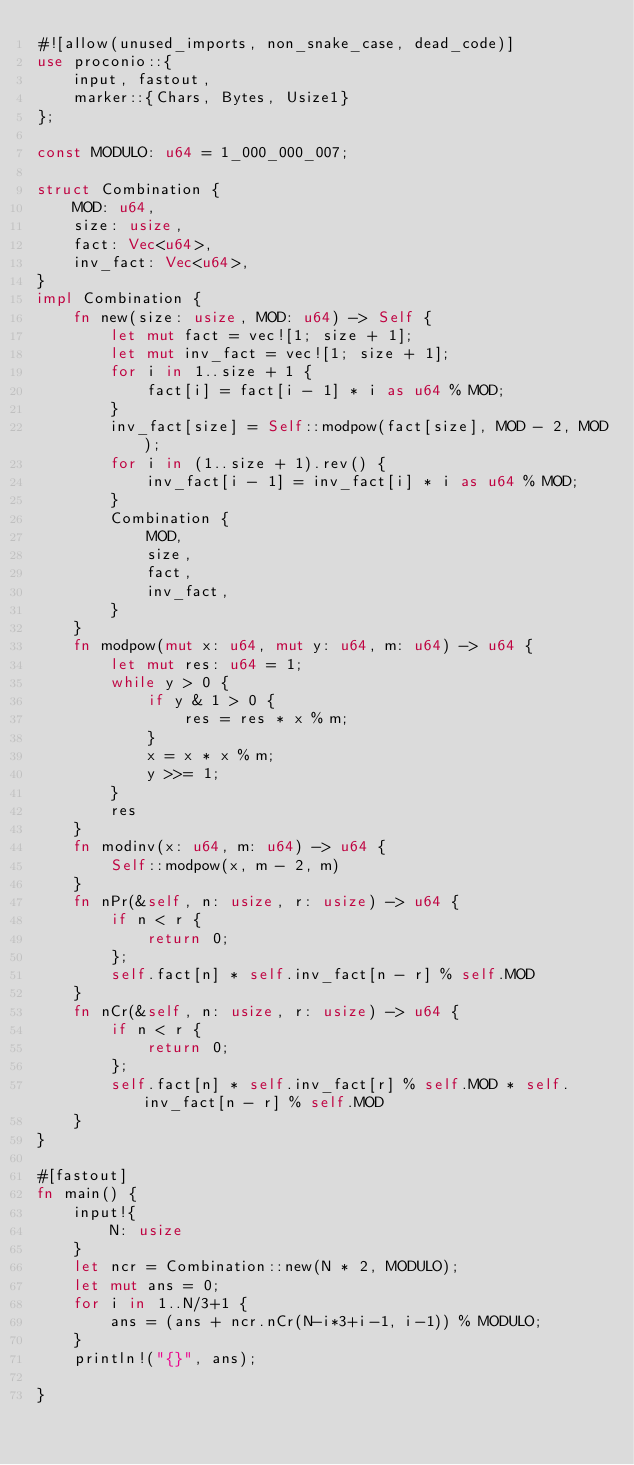Convert code to text. <code><loc_0><loc_0><loc_500><loc_500><_Rust_>#![allow(unused_imports, non_snake_case, dead_code)]
use proconio::{
    input, fastout,
    marker::{Chars, Bytes, Usize1}
};

const MODULO: u64 = 1_000_000_007;

struct Combination {
    MOD: u64,
    size: usize,
    fact: Vec<u64>,
    inv_fact: Vec<u64>,
}
impl Combination {
    fn new(size: usize, MOD: u64) -> Self {
        let mut fact = vec![1; size + 1];
        let mut inv_fact = vec![1; size + 1];
        for i in 1..size + 1 {
            fact[i] = fact[i - 1] * i as u64 % MOD;
        }
        inv_fact[size] = Self::modpow(fact[size], MOD - 2, MOD);
        for i in (1..size + 1).rev() {
            inv_fact[i - 1] = inv_fact[i] * i as u64 % MOD;
        }
        Combination {
            MOD,
            size,
            fact,
            inv_fact,
        }
    }
    fn modpow(mut x: u64, mut y: u64, m: u64) -> u64 {
        let mut res: u64 = 1;
        while y > 0 {
            if y & 1 > 0 {
                res = res * x % m;
            }
            x = x * x % m;
            y >>= 1;
        }
        res
    }
    fn modinv(x: u64, m: u64) -> u64 {
        Self::modpow(x, m - 2, m)
    }
    fn nPr(&self, n: usize, r: usize) -> u64 {
        if n < r {
            return 0;
        };
        self.fact[n] * self.inv_fact[n - r] % self.MOD
    }
    fn nCr(&self, n: usize, r: usize) -> u64 {
        if n < r {
            return 0;
        };
        self.fact[n] * self.inv_fact[r] % self.MOD * self.inv_fact[n - r] % self.MOD
    }
}

#[fastout]
fn main() {
    input!{
        N: usize
    }
    let ncr = Combination::new(N * 2, MODULO);
    let mut ans = 0;
    for i in 1..N/3+1 {
        ans = (ans + ncr.nCr(N-i*3+i-1, i-1)) % MODULO;
    }
    println!("{}", ans);

}
</code> 